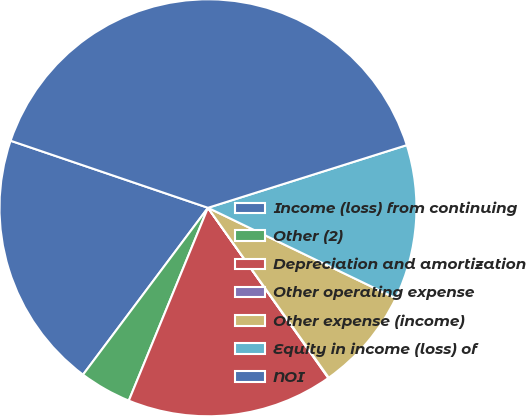Convert chart to OTSL. <chart><loc_0><loc_0><loc_500><loc_500><pie_chart><fcel>Income (loss) from continuing<fcel>Other (2)<fcel>Depreciation and amortization<fcel>Other operating expense<fcel>Other expense (income)<fcel>Equity in income (loss) of<fcel>NOI<nl><fcel>19.99%<fcel>4.03%<fcel>16.0%<fcel>0.04%<fcel>8.02%<fcel>12.01%<fcel>39.94%<nl></chart> 